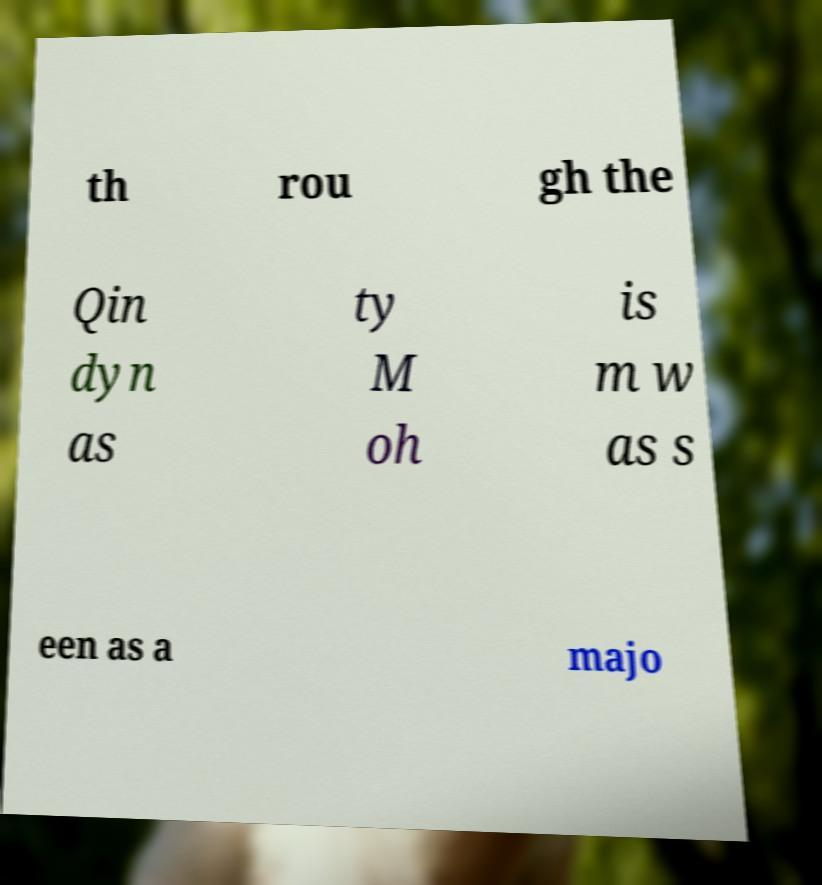I need the written content from this picture converted into text. Can you do that? th rou gh the Qin dyn as ty M oh is m w as s een as a majo 